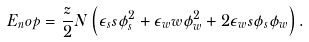<formula> <loc_0><loc_0><loc_500><loc_500>E _ { n } o p = \frac { z } { 2 } N \left ( \epsilon _ { s } s \phi _ { s } ^ { 2 } + \epsilon _ { w } w \phi _ { w } ^ { 2 } + 2 \epsilon _ { w } s \phi _ { s } \phi _ { w } \right ) .</formula> 